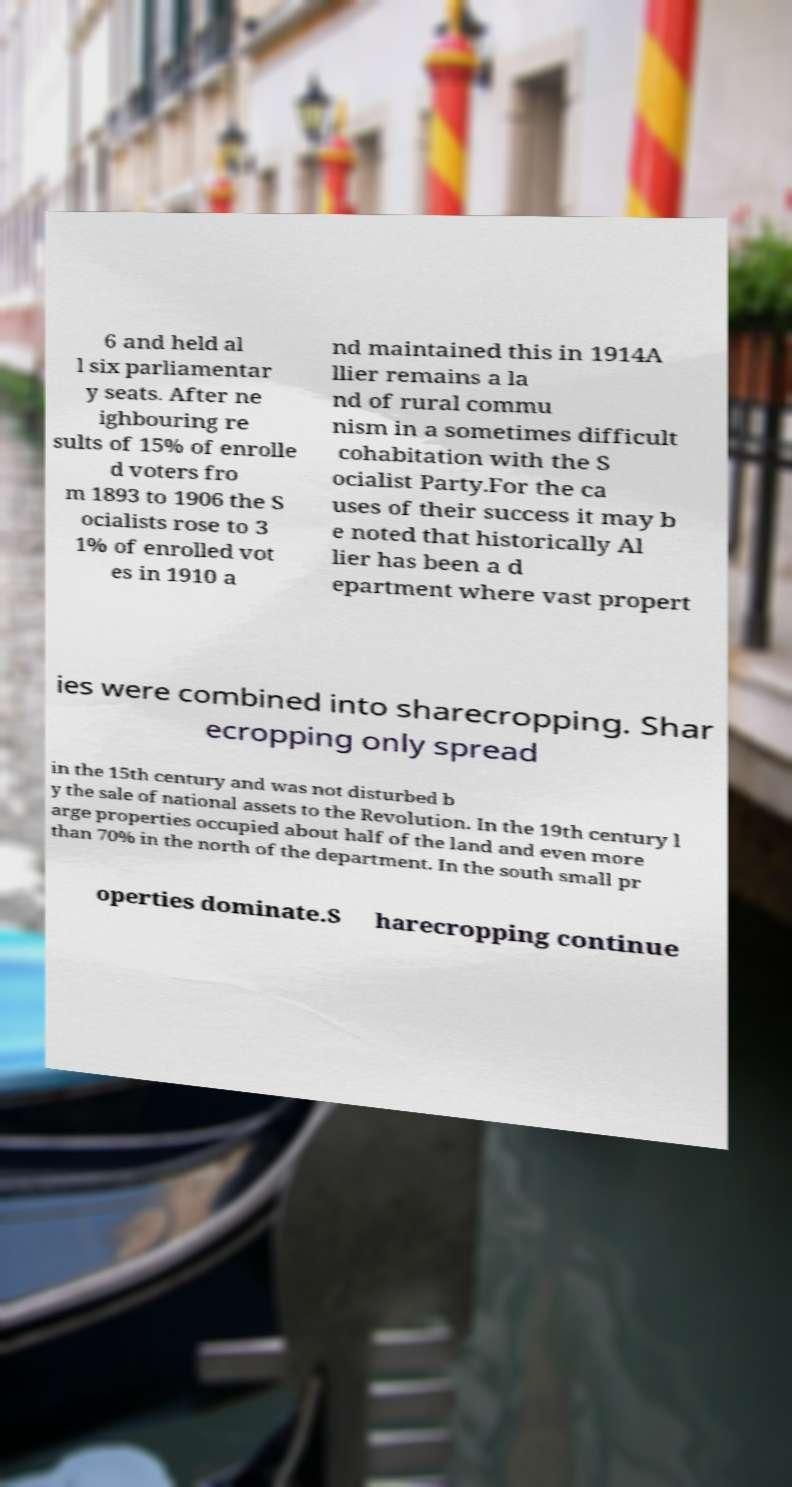Could you assist in decoding the text presented in this image and type it out clearly? 6 and held al l six parliamentar y seats. After ne ighbouring re sults of 15% of enrolle d voters fro m 1893 to 1906 the S ocialists rose to 3 1% of enrolled vot es in 1910 a nd maintained this in 1914A llier remains a la nd of rural commu nism in a sometimes difficult cohabitation with the S ocialist Party.For the ca uses of their success it may b e noted that historically Al lier has been a d epartment where vast propert ies were combined into sharecropping. Shar ecropping only spread in the 15th century and was not disturbed b y the sale of national assets to the Revolution. In the 19th century l arge properties occupied about half of the land and even more than 70% in the north of the department. In the south small pr operties dominate.S harecropping continue 